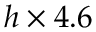<formula> <loc_0><loc_0><loc_500><loc_500>h \times 4 . 6</formula> 